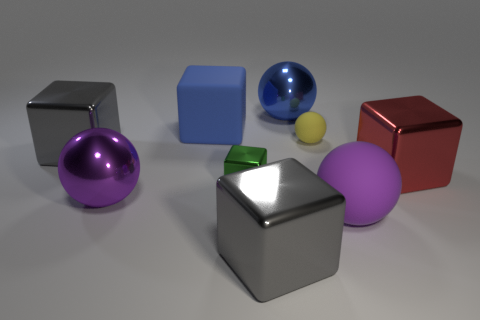Subtract all red blocks. How many blocks are left? 4 Subtract all matte blocks. How many blocks are left? 4 Subtract all cyan cubes. Subtract all blue cylinders. How many cubes are left? 5 Subtract all balls. How many objects are left? 5 Subtract all metallic spheres. Subtract all red things. How many objects are left? 6 Add 4 large matte blocks. How many large matte blocks are left? 5 Add 7 metal cylinders. How many metal cylinders exist? 7 Subtract 0 purple cylinders. How many objects are left? 9 